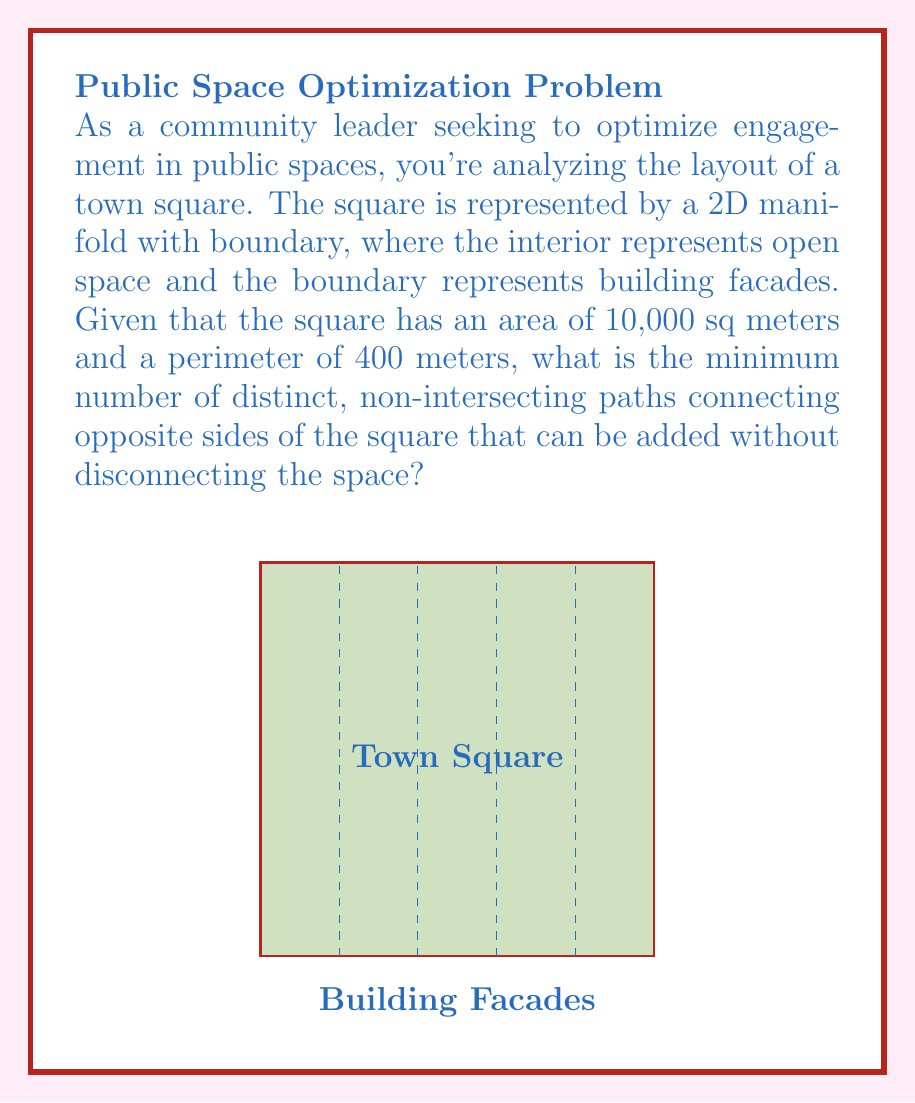Teach me how to tackle this problem. To solve this problem, we'll use concepts from topology and graph theory:

1) First, we need to understand what the question is asking. We're looking for the maximum number of paths that can be added without disconnecting the space. In topological terms, we're finding the genus of the surface.

2) The square is a 2D manifold with boundary. Its Euler characteristic (χ) is 1, as it's topologically equivalent to a disk.

3) The Euler-Poincaré formula relates the Euler characteristic to the genus (g) of a surface:

   $$χ = 2 - 2g$$

4) Solving for g:

   $$g = \frac{2 - χ}{2} = \frac{2 - 1}{2} = \frac{1}{2}$$

5) The genus must be a whole number, so we round up to 1.

6) Each non-intersecting path we add increases the genus by 1. Therefore, we can add 1 path to reach a genus of 1.

7) Adding more paths would increase the genus beyond 1, which would disconnect the space.

Thus, the minimum (and maximum) number of distinct, non-intersecting paths that can be added without disconnecting the space is 1.
Answer: 1 